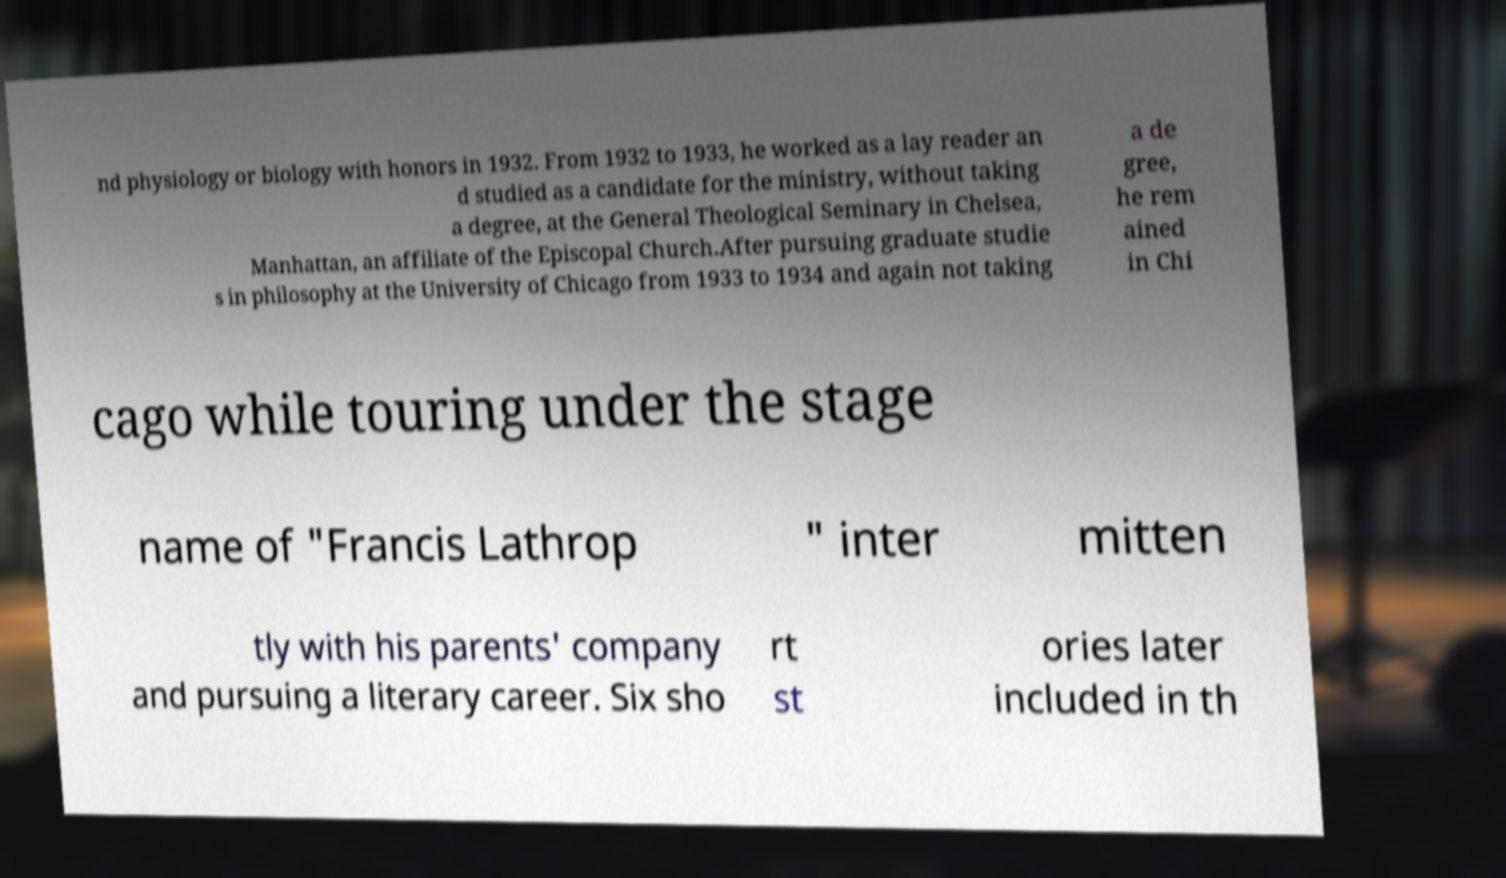Could you assist in decoding the text presented in this image and type it out clearly? nd physiology or biology with honors in 1932. From 1932 to 1933, he worked as a lay reader an d studied as a candidate for the ministry, without taking a degree, at the General Theological Seminary in Chelsea, Manhattan, an affiliate of the Episcopal Church.After pursuing graduate studie s in philosophy at the University of Chicago from 1933 to 1934 and again not taking a de gree, he rem ained in Chi cago while touring under the stage name of "Francis Lathrop " inter mitten tly with his parents' company and pursuing a literary career. Six sho rt st ories later included in th 